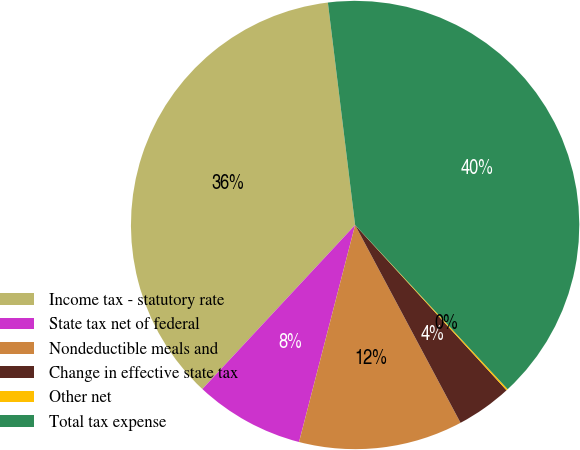<chart> <loc_0><loc_0><loc_500><loc_500><pie_chart><fcel>Income tax - statutory rate<fcel>State tax net of federal<fcel>Nondeductible meals and<fcel>Change in effective state tax<fcel>Other net<fcel>Total tax expense<nl><fcel>36.13%<fcel>7.91%<fcel>11.82%<fcel>4.01%<fcel>0.11%<fcel>40.03%<nl></chart> 